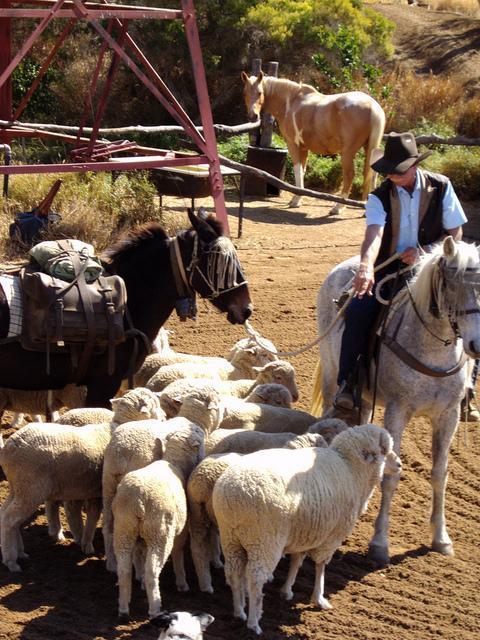How many horses can you see?
Give a very brief answer. 3. How many sheep are there?
Give a very brief answer. 9. 